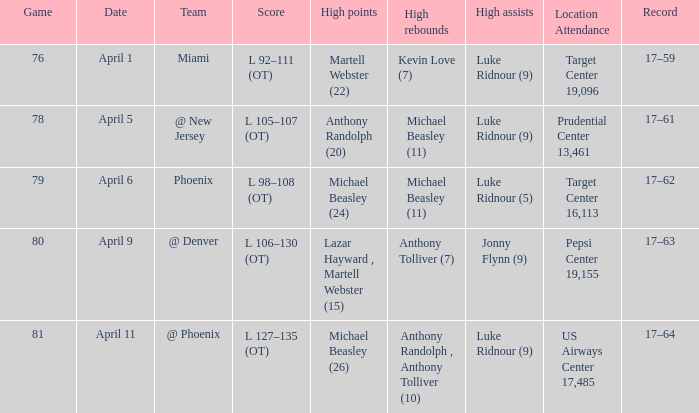How many different results for high rebounds were there for game number 76? 1.0. 